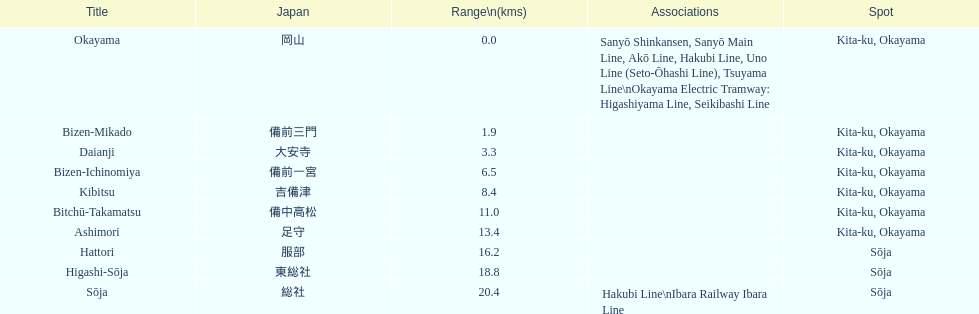Which has the most distance, hattori or kibitsu? Hattori. 